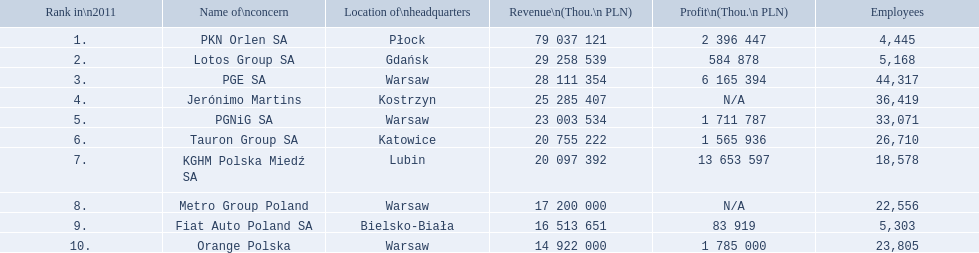Which enterprise has its central office in warsaw? PGE SA, PGNiG SA, Metro Group Poland. Which ones among them made a profit? PGE SA, PGNiG SA. How many staff members are there in the enterprise with the smallest profit? 33,071. 